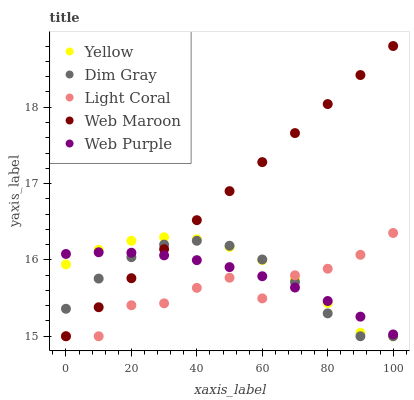Does Light Coral have the minimum area under the curve?
Answer yes or no. Yes. Does Web Maroon have the maximum area under the curve?
Answer yes or no. Yes. Does Web Purple have the minimum area under the curve?
Answer yes or no. No. Does Web Purple have the maximum area under the curve?
Answer yes or no. No. Is Web Maroon the smoothest?
Answer yes or no. Yes. Is Light Coral the roughest?
Answer yes or no. Yes. Is Web Purple the smoothest?
Answer yes or no. No. Is Web Purple the roughest?
Answer yes or no. No. Does Light Coral have the lowest value?
Answer yes or no. Yes. Does Web Purple have the lowest value?
Answer yes or no. No. Does Web Maroon have the highest value?
Answer yes or no. Yes. Does Dim Gray have the highest value?
Answer yes or no. No. Does Web Maroon intersect Yellow?
Answer yes or no. Yes. Is Web Maroon less than Yellow?
Answer yes or no. No. Is Web Maroon greater than Yellow?
Answer yes or no. No. 